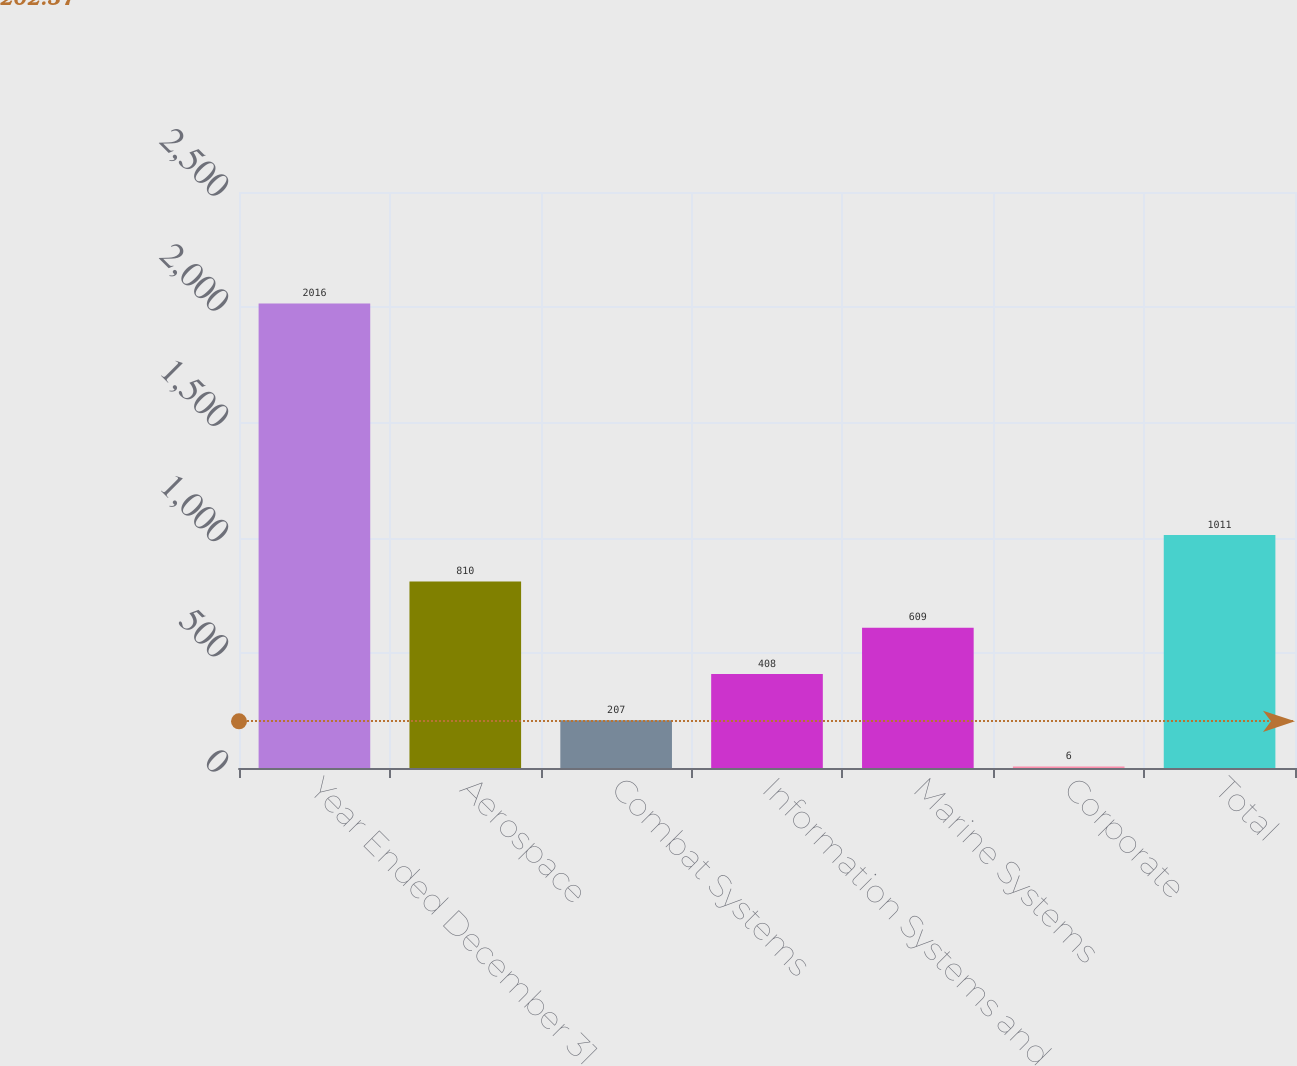Convert chart. <chart><loc_0><loc_0><loc_500><loc_500><bar_chart><fcel>Year Ended December 31<fcel>Aerospace<fcel>Combat Systems<fcel>Information Systems and<fcel>Marine Systems<fcel>Corporate<fcel>Total<nl><fcel>2016<fcel>810<fcel>207<fcel>408<fcel>609<fcel>6<fcel>1011<nl></chart> 